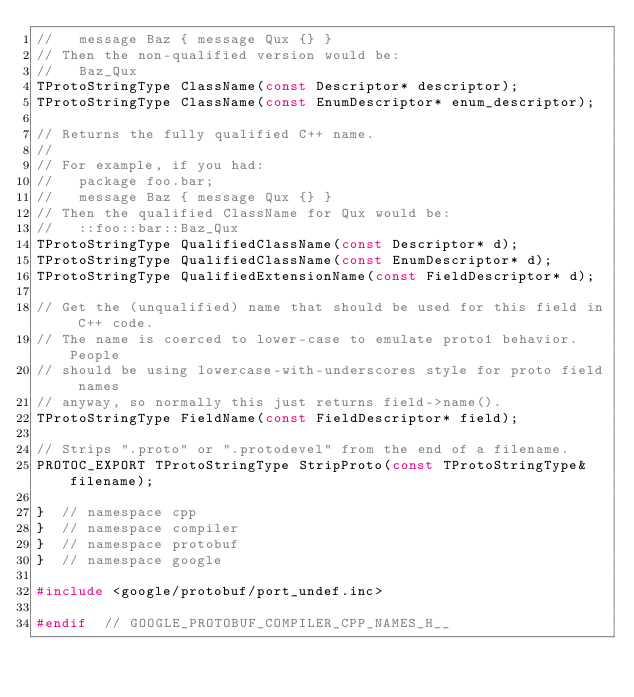<code> <loc_0><loc_0><loc_500><loc_500><_C_>//   message Baz { message Qux {} }
// Then the non-qualified version would be:
//   Baz_Qux
TProtoStringType ClassName(const Descriptor* descriptor);
TProtoStringType ClassName(const EnumDescriptor* enum_descriptor);

// Returns the fully qualified C++ name.
//
// For example, if you had:
//   package foo.bar;
//   message Baz { message Qux {} }
// Then the qualified ClassName for Qux would be:
//   ::foo::bar::Baz_Qux
TProtoStringType QualifiedClassName(const Descriptor* d);
TProtoStringType QualifiedClassName(const EnumDescriptor* d);
TProtoStringType QualifiedExtensionName(const FieldDescriptor* d);

// Get the (unqualified) name that should be used for this field in C++ code.
// The name is coerced to lower-case to emulate proto1 behavior.  People
// should be using lowercase-with-underscores style for proto field names
// anyway, so normally this just returns field->name().
TProtoStringType FieldName(const FieldDescriptor* field);

// Strips ".proto" or ".protodevel" from the end of a filename.
PROTOC_EXPORT TProtoStringType StripProto(const TProtoStringType& filename);

}  // namespace cpp
}  // namespace compiler
}  // namespace protobuf
}  // namespace google

#include <google/protobuf/port_undef.inc>

#endif  // GOOGLE_PROTOBUF_COMPILER_CPP_NAMES_H__
</code> 